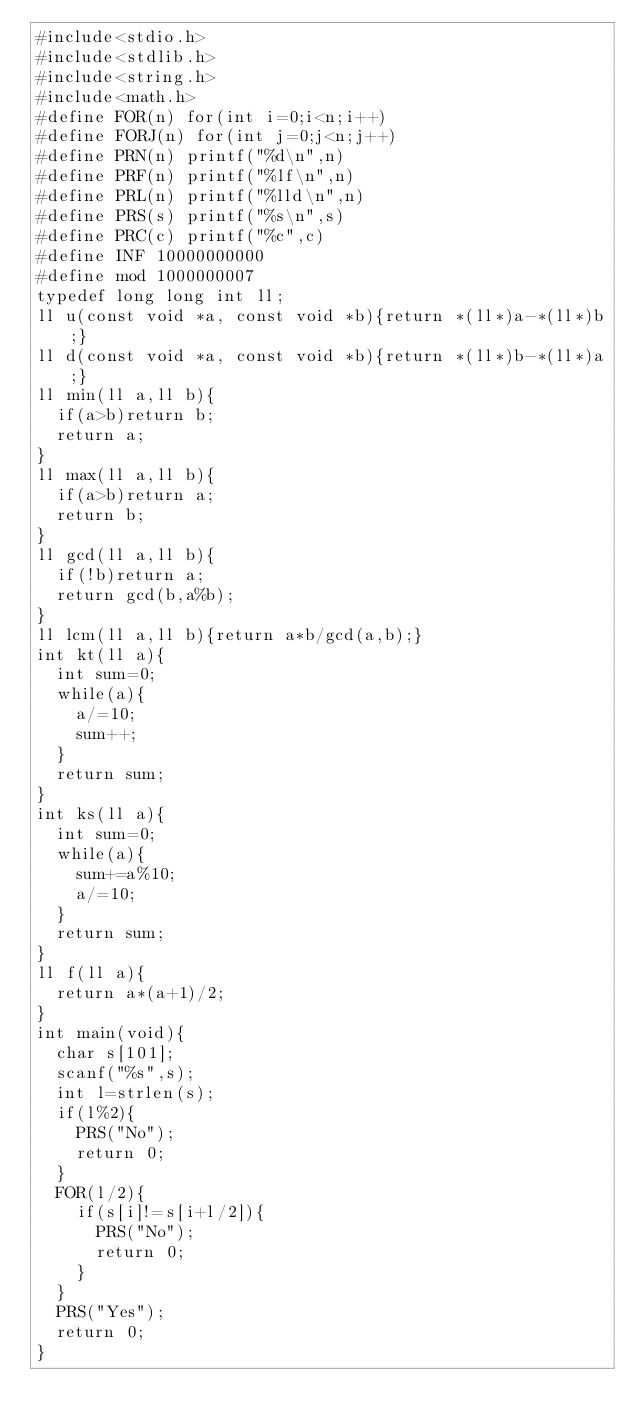Convert code to text. <code><loc_0><loc_0><loc_500><loc_500><_C_>#include<stdio.h>
#include<stdlib.h>
#include<string.h>
#include<math.h>
#define FOR(n) for(int i=0;i<n;i++)
#define FORJ(n) for(int j=0;j<n;j++)
#define PRN(n) printf("%d\n",n)
#define PRF(n) printf("%lf\n",n)
#define PRL(n) printf("%lld\n",n)
#define PRS(s) printf("%s\n",s)
#define PRC(c) printf("%c",c)
#define INF 10000000000
#define mod 1000000007
typedef long long int ll;
ll u(const void *a, const void *b){return *(ll*)a-*(ll*)b;}
ll d(const void *a, const void *b){return *(ll*)b-*(ll*)a;}
ll min(ll a,ll b){
  if(a>b)return b;
  return a;
}
ll max(ll a,ll b){
  if(a>b)return a;
  return b;
}
ll gcd(ll a,ll b){
  if(!b)return a;
  return gcd(b,a%b);
}
ll lcm(ll a,ll b){return a*b/gcd(a,b);}
int kt(ll a){
  int sum=0;
  while(a){
    a/=10;
    sum++;
  }
  return sum;
}
int ks(ll a){
  int sum=0;
  while(a){
    sum+=a%10;
    a/=10;
  }
  return sum;
}
ll f(ll a){
  return a*(a+1)/2;
}
int main(void){
  char s[101];
  scanf("%s",s);
  int l=strlen(s);
  if(l%2){
    PRS("No");
    return 0;
  }
  FOR(l/2){
    if(s[i]!=s[i+l/2]){
      PRS("No");
      return 0;
    }
  }
  PRS("Yes");
  return 0;
}
</code> 